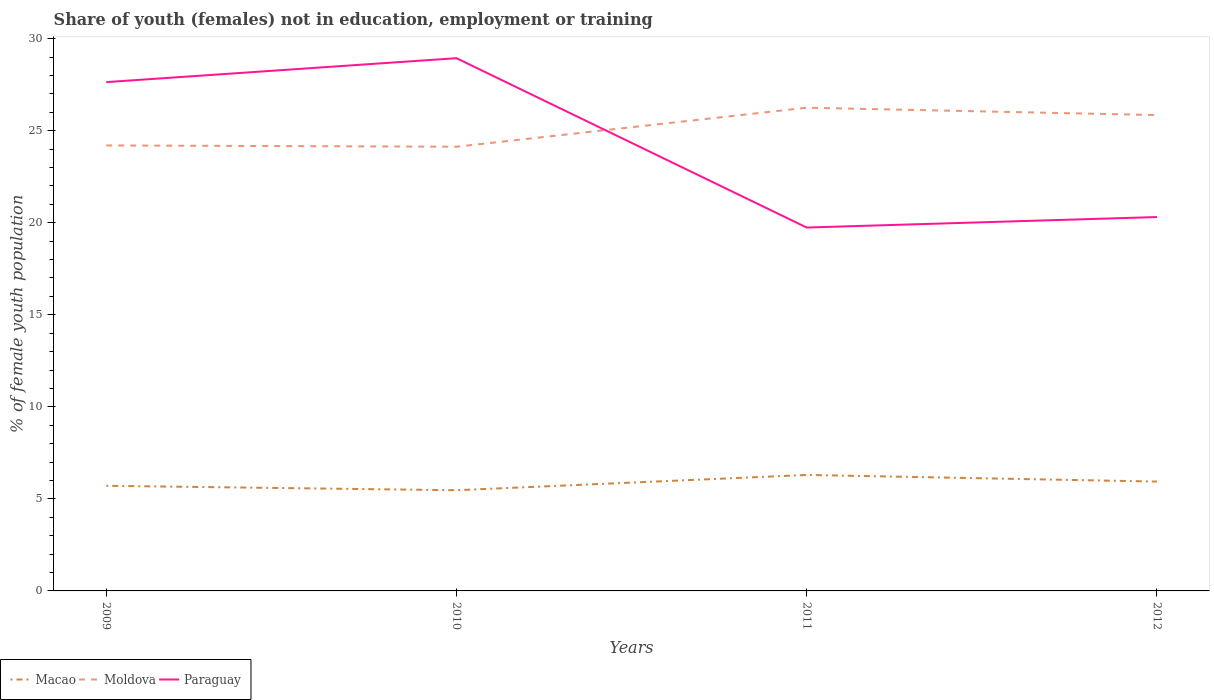Does the line corresponding to Paraguay intersect with the line corresponding to Macao?
Provide a short and direct response. No. Is the number of lines equal to the number of legend labels?
Offer a terse response. Yes. Across all years, what is the maximum percentage of unemployed female population in in Macao?
Your response must be concise. 5.47. What is the total percentage of unemployed female population in in Paraguay in the graph?
Offer a terse response. 7.9. What is the difference between the highest and the second highest percentage of unemployed female population in in Paraguay?
Give a very brief answer. 9.2. How many lines are there?
Your response must be concise. 3. What is the difference between two consecutive major ticks on the Y-axis?
Give a very brief answer. 5. Are the values on the major ticks of Y-axis written in scientific E-notation?
Your answer should be very brief. No. Does the graph contain grids?
Your answer should be compact. No. Where does the legend appear in the graph?
Your response must be concise. Bottom left. What is the title of the graph?
Provide a succinct answer. Share of youth (females) not in education, employment or training. What is the label or title of the X-axis?
Offer a terse response. Years. What is the label or title of the Y-axis?
Your answer should be compact. % of female youth population. What is the % of female youth population of Macao in 2009?
Your answer should be very brief. 5.71. What is the % of female youth population of Moldova in 2009?
Offer a terse response. 24.2. What is the % of female youth population in Paraguay in 2009?
Give a very brief answer. 27.64. What is the % of female youth population of Macao in 2010?
Your answer should be compact. 5.47. What is the % of female youth population in Moldova in 2010?
Your response must be concise. 24.13. What is the % of female youth population of Paraguay in 2010?
Your response must be concise. 28.94. What is the % of female youth population in Macao in 2011?
Keep it short and to the point. 6.3. What is the % of female youth population in Moldova in 2011?
Make the answer very short. 26.25. What is the % of female youth population in Paraguay in 2011?
Make the answer very short. 19.74. What is the % of female youth population of Macao in 2012?
Offer a terse response. 5.94. What is the % of female youth population in Moldova in 2012?
Keep it short and to the point. 25.85. What is the % of female youth population in Paraguay in 2012?
Ensure brevity in your answer.  20.31. Across all years, what is the maximum % of female youth population in Macao?
Your answer should be compact. 6.3. Across all years, what is the maximum % of female youth population of Moldova?
Provide a short and direct response. 26.25. Across all years, what is the maximum % of female youth population of Paraguay?
Make the answer very short. 28.94. Across all years, what is the minimum % of female youth population of Macao?
Provide a short and direct response. 5.47. Across all years, what is the minimum % of female youth population of Moldova?
Your answer should be very brief. 24.13. Across all years, what is the minimum % of female youth population in Paraguay?
Give a very brief answer. 19.74. What is the total % of female youth population of Macao in the graph?
Make the answer very short. 23.42. What is the total % of female youth population in Moldova in the graph?
Give a very brief answer. 100.43. What is the total % of female youth population of Paraguay in the graph?
Provide a succinct answer. 96.63. What is the difference between the % of female youth population in Macao in 2009 and that in 2010?
Keep it short and to the point. 0.24. What is the difference between the % of female youth population of Moldova in 2009 and that in 2010?
Ensure brevity in your answer.  0.07. What is the difference between the % of female youth population in Paraguay in 2009 and that in 2010?
Keep it short and to the point. -1.3. What is the difference between the % of female youth population of Macao in 2009 and that in 2011?
Keep it short and to the point. -0.59. What is the difference between the % of female youth population of Moldova in 2009 and that in 2011?
Make the answer very short. -2.05. What is the difference between the % of female youth population in Macao in 2009 and that in 2012?
Your answer should be very brief. -0.23. What is the difference between the % of female youth population in Moldova in 2009 and that in 2012?
Make the answer very short. -1.65. What is the difference between the % of female youth population of Paraguay in 2009 and that in 2012?
Your answer should be very brief. 7.33. What is the difference between the % of female youth population in Macao in 2010 and that in 2011?
Make the answer very short. -0.83. What is the difference between the % of female youth population of Moldova in 2010 and that in 2011?
Your answer should be very brief. -2.12. What is the difference between the % of female youth population of Paraguay in 2010 and that in 2011?
Give a very brief answer. 9.2. What is the difference between the % of female youth population of Macao in 2010 and that in 2012?
Keep it short and to the point. -0.47. What is the difference between the % of female youth population of Moldova in 2010 and that in 2012?
Your answer should be very brief. -1.72. What is the difference between the % of female youth population in Paraguay in 2010 and that in 2012?
Your answer should be compact. 8.63. What is the difference between the % of female youth population in Macao in 2011 and that in 2012?
Your answer should be very brief. 0.36. What is the difference between the % of female youth population of Paraguay in 2011 and that in 2012?
Your answer should be compact. -0.57. What is the difference between the % of female youth population in Macao in 2009 and the % of female youth population in Moldova in 2010?
Provide a succinct answer. -18.42. What is the difference between the % of female youth population of Macao in 2009 and the % of female youth population of Paraguay in 2010?
Keep it short and to the point. -23.23. What is the difference between the % of female youth population in Moldova in 2009 and the % of female youth population in Paraguay in 2010?
Offer a terse response. -4.74. What is the difference between the % of female youth population in Macao in 2009 and the % of female youth population in Moldova in 2011?
Your answer should be very brief. -20.54. What is the difference between the % of female youth population in Macao in 2009 and the % of female youth population in Paraguay in 2011?
Give a very brief answer. -14.03. What is the difference between the % of female youth population of Moldova in 2009 and the % of female youth population of Paraguay in 2011?
Give a very brief answer. 4.46. What is the difference between the % of female youth population in Macao in 2009 and the % of female youth population in Moldova in 2012?
Provide a succinct answer. -20.14. What is the difference between the % of female youth population in Macao in 2009 and the % of female youth population in Paraguay in 2012?
Offer a terse response. -14.6. What is the difference between the % of female youth population in Moldova in 2009 and the % of female youth population in Paraguay in 2012?
Make the answer very short. 3.89. What is the difference between the % of female youth population of Macao in 2010 and the % of female youth population of Moldova in 2011?
Offer a terse response. -20.78. What is the difference between the % of female youth population in Macao in 2010 and the % of female youth population in Paraguay in 2011?
Make the answer very short. -14.27. What is the difference between the % of female youth population in Moldova in 2010 and the % of female youth population in Paraguay in 2011?
Your answer should be very brief. 4.39. What is the difference between the % of female youth population in Macao in 2010 and the % of female youth population in Moldova in 2012?
Provide a succinct answer. -20.38. What is the difference between the % of female youth population in Macao in 2010 and the % of female youth population in Paraguay in 2012?
Offer a terse response. -14.84. What is the difference between the % of female youth population in Moldova in 2010 and the % of female youth population in Paraguay in 2012?
Make the answer very short. 3.82. What is the difference between the % of female youth population in Macao in 2011 and the % of female youth population in Moldova in 2012?
Ensure brevity in your answer.  -19.55. What is the difference between the % of female youth population of Macao in 2011 and the % of female youth population of Paraguay in 2012?
Your response must be concise. -14.01. What is the difference between the % of female youth population in Moldova in 2011 and the % of female youth population in Paraguay in 2012?
Your response must be concise. 5.94. What is the average % of female youth population in Macao per year?
Your response must be concise. 5.86. What is the average % of female youth population of Moldova per year?
Your answer should be very brief. 25.11. What is the average % of female youth population in Paraguay per year?
Make the answer very short. 24.16. In the year 2009, what is the difference between the % of female youth population in Macao and % of female youth population in Moldova?
Ensure brevity in your answer.  -18.49. In the year 2009, what is the difference between the % of female youth population in Macao and % of female youth population in Paraguay?
Your answer should be compact. -21.93. In the year 2009, what is the difference between the % of female youth population of Moldova and % of female youth population of Paraguay?
Provide a short and direct response. -3.44. In the year 2010, what is the difference between the % of female youth population of Macao and % of female youth population of Moldova?
Give a very brief answer. -18.66. In the year 2010, what is the difference between the % of female youth population in Macao and % of female youth population in Paraguay?
Provide a short and direct response. -23.47. In the year 2010, what is the difference between the % of female youth population of Moldova and % of female youth population of Paraguay?
Your answer should be very brief. -4.81. In the year 2011, what is the difference between the % of female youth population in Macao and % of female youth population in Moldova?
Ensure brevity in your answer.  -19.95. In the year 2011, what is the difference between the % of female youth population in Macao and % of female youth population in Paraguay?
Provide a succinct answer. -13.44. In the year 2011, what is the difference between the % of female youth population in Moldova and % of female youth population in Paraguay?
Your answer should be compact. 6.51. In the year 2012, what is the difference between the % of female youth population of Macao and % of female youth population of Moldova?
Offer a very short reply. -19.91. In the year 2012, what is the difference between the % of female youth population in Macao and % of female youth population in Paraguay?
Offer a very short reply. -14.37. In the year 2012, what is the difference between the % of female youth population in Moldova and % of female youth population in Paraguay?
Offer a very short reply. 5.54. What is the ratio of the % of female youth population of Macao in 2009 to that in 2010?
Offer a terse response. 1.04. What is the ratio of the % of female youth population of Paraguay in 2009 to that in 2010?
Keep it short and to the point. 0.96. What is the ratio of the % of female youth population of Macao in 2009 to that in 2011?
Make the answer very short. 0.91. What is the ratio of the % of female youth population in Moldova in 2009 to that in 2011?
Give a very brief answer. 0.92. What is the ratio of the % of female youth population in Paraguay in 2009 to that in 2011?
Make the answer very short. 1.4. What is the ratio of the % of female youth population of Macao in 2009 to that in 2012?
Make the answer very short. 0.96. What is the ratio of the % of female youth population of Moldova in 2009 to that in 2012?
Give a very brief answer. 0.94. What is the ratio of the % of female youth population in Paraguay in 2009 to that in 2012?
Offer a very short reply. 1.36. What is the ratio of the % of female youth population in Macao in 2010 to that in 2011?
Your answer should be very brief. 0.87. What is the ratio of the % of female youth population in Moldova in 2010 to that in 2011?
Your answer should be compact. 0.92. What is the ratio of the % of female youth population of Paraguay in 2010 to that in 2011?
Keep it short and to the point. 1.47. What is the ratio of the % of female youth population in Macao in 2010 to that in 2012?
Ensure brevity in your answer.  0.92. What is the ratio of the % of female youth population of Moldova in 2010 to that in 2012?
Your answer should be compact. 0.93. What is the ratio of the % of female youth population of Paraguay in 2010 to that in 2012?
Ensure brevity in your answer.  1.42. What is the ratio of the % of female youth population in Macao in 2011 to that in 2012?
Your answer should be compact. 1.06. What is the ratio of the % of female youth population of Moldova in 2011 to that in 2012?
Offer a terse response. 1.02. What is the ratio of the % of female youth population of Paraguay in 2011 to that in 2012?
Your answer should be very brief. 0.97. What is the difference between the highest and the second highest % of female youth population of Macao?
Your answer should be very brief. 0.36. What is the difference between the highest and the lowest % of female youth population of Macao?
Provide a succinct answer. 0.83. What is the difference between the highest and the lowest % of female youth population of Moldova?
Ensure brevity in your answer.  2.12. What is the difference between the highest and the lowest % of female youth population of Paraguay?
Keep it short and to the point. 9.2. 